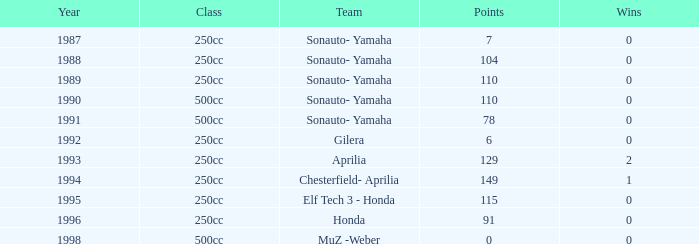What is the largest number of points the team with 0 successes had pre-1992? 110.0. 